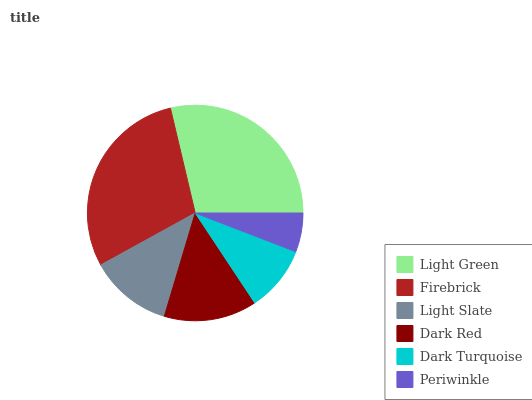Is Periwinkle the minimum?
Answer yes or no. Yes. Is Firebrick the maximum?
Answer yes or no. Yes. Is Light Slate the minimum?
Answer yes or no. No. Is Light Slate the maximum?
Answer yes or no. No. Is Firebrick greater than Light Slate?
Answer yes or no. Yes. Is Light Slate less than Firebrick?
Answer yes or no. Yes. Is Light Slate greater than Firebrick?
Answer yes or no. No. Is Firebrick less than Light Slate?
Answer yes or no. No. Is Dark Red the high median?
Answer yes or no. Yes. Is Light Slate the low median?
Answer yes or no. Yes. Is Periwinkle the high median?
Answer yes or no. No. Is Dark Turquoise the low median?
Answer yes or no. No. 